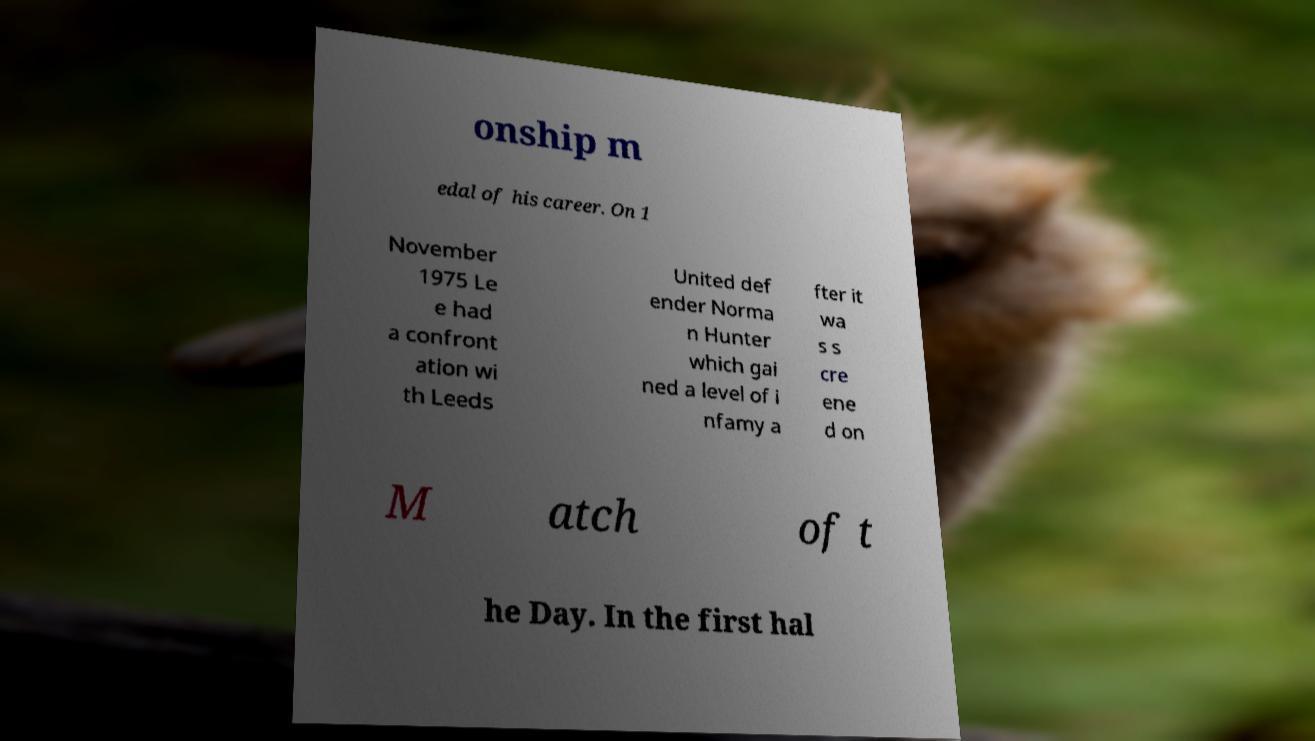For documentation purposes, I need the text within this image transcribed. Could you provide that? onship m edal of his career. On 1 November 1975 Le e had a confront ation wi th Leeds United def ender Norma n Hunter which gai ned a level of i nfamy a fter it wa s s cre ene d on M atch of t he Day. In the first hal 